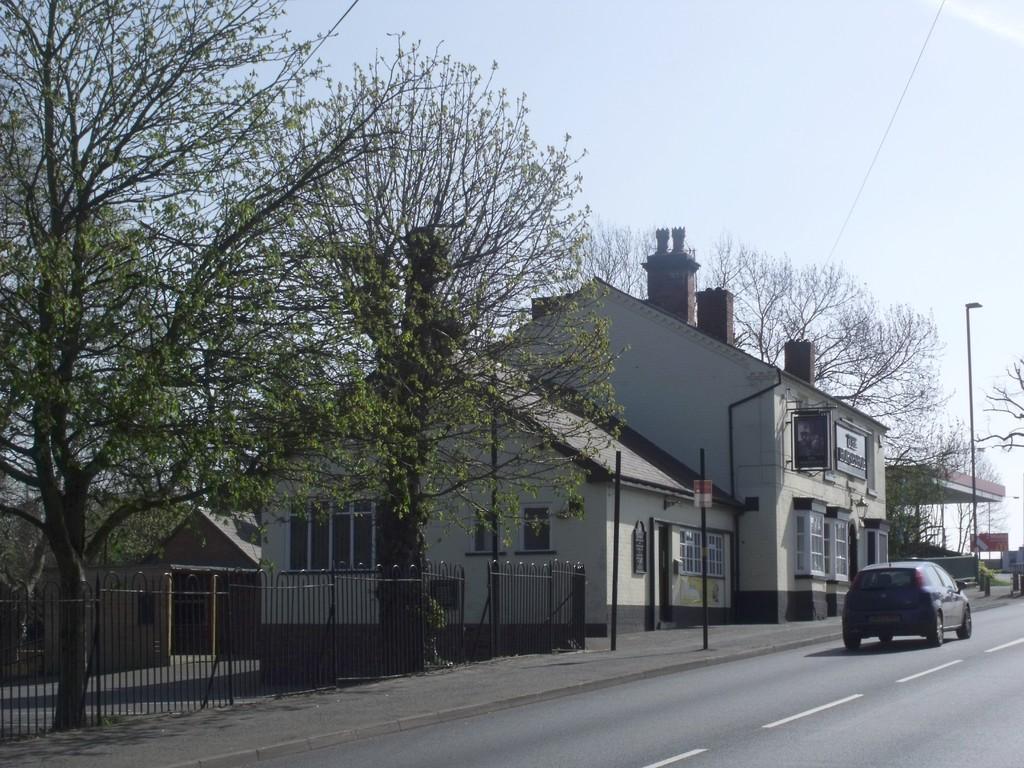How would you summarize this image in a sentence or two? In the image there is a car going on road with buildings beside it and trees on either side and above its sky. 